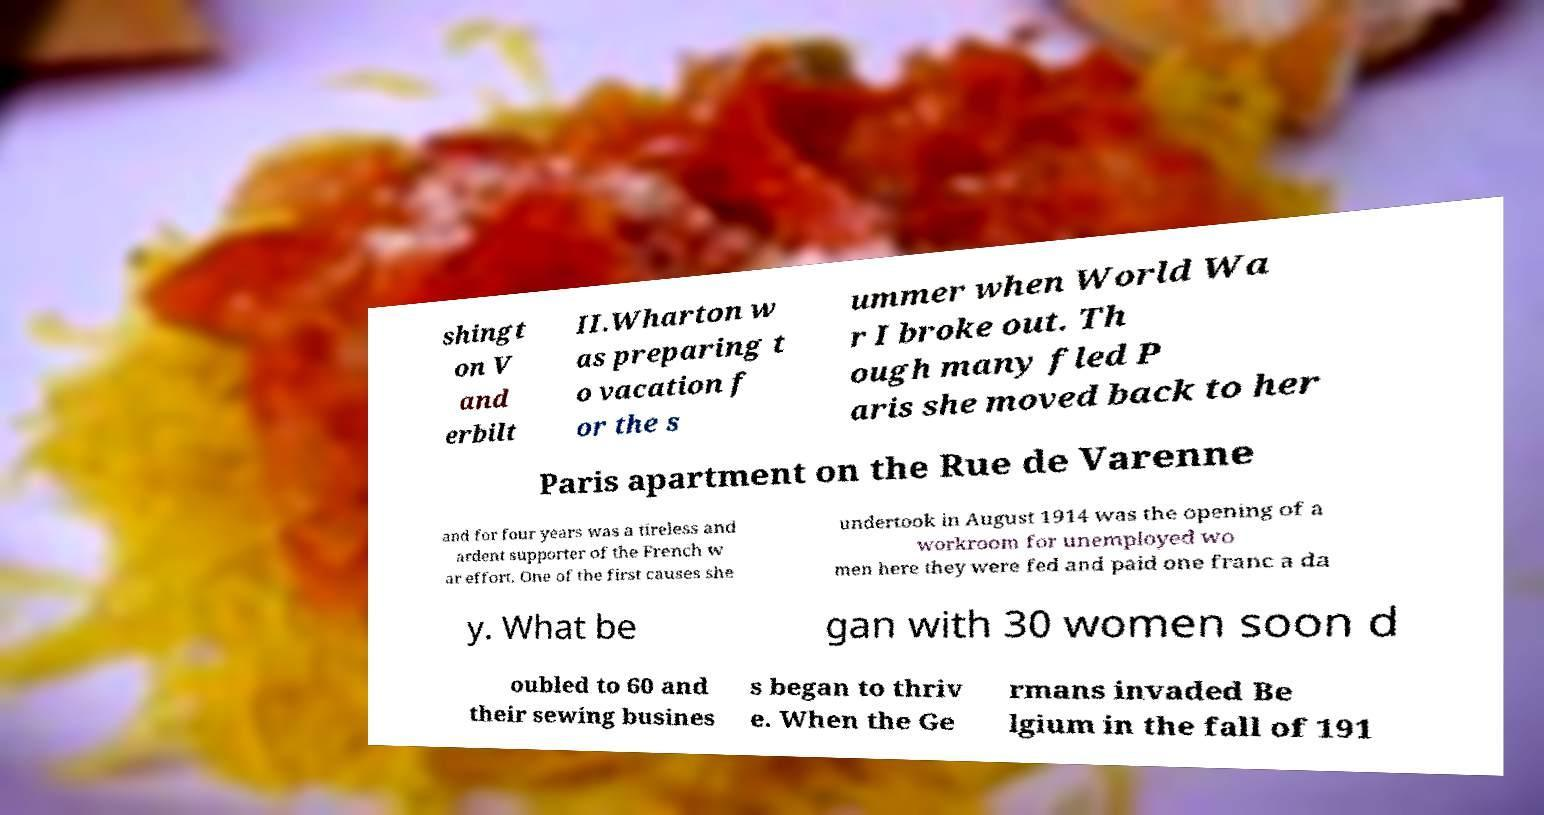Please read and relay the text visible in this image. What does it say? shingt on V and erbilt II.Wharton w as preparing t o vacation f or the s ummer when World Wa r I broke out. Th ough many fled P aris she moved back to her Paris apartment on the Rue de Varenne and for four years was a tireless and ardent supporter of the French w ar effort. One of the first causes she undertook in August 1914 was the opening of a workroom for unemployed wo men here they were fed and paid one franc a da y. What be gan with 30 women soon d oubled to 60 and their sewing busines s began to thriv e. When the Ge rmans invaded Be lgium in the fall of 191 